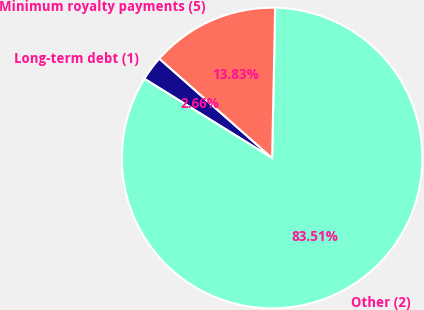Convert chart to OTSL. <chart><loc_0><loc_0><loc_500><loc_500><pie_chart><fcel>Long-term debt (1)<fcel>Other (2)<fcel>Minimum royalty payments (5)<nl><fcel>2.66%<fcel>83.51%<fcel>13.83%<nl></chart> 